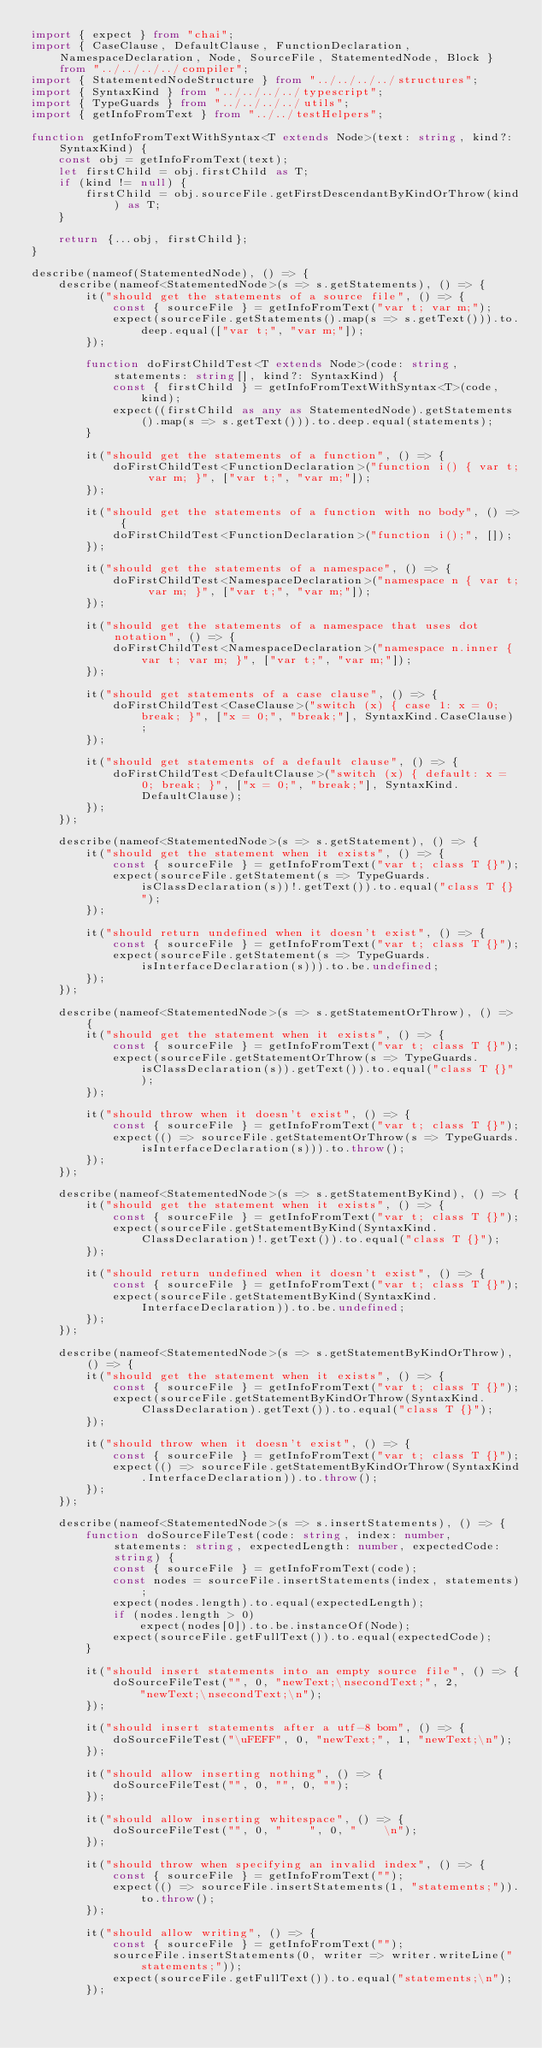<code> <loc_0><loc_0><loc_500><loc_500><_TypeScript_>import { expect } from "chai";
import { CaseClause, DefaultClause, FunctionDeclaration, NamespaceDeclaration, Node, SourceFile, StatementedNode, Block } from "../../../../compiler";
import { StatementedNodeStructure } from "../../../../structures";
import { SyntaxKind } from "../../../../typescript";
import { TypeGuards } from "../../../../utils";
import { getInfoFromText } from "../../testHelpers";

function getInfoFromTextWithSyntax<T extends Node>(text: string, kind?: SyntaxKind) {
    const obj = getInfoFromText(text);
    let firstChild = obj.firstChild as T;
    if (kind != null) {
        firstChild = obj.sourceFile.getFirstDescendantByKindOrThrow(kind) as T;
    }

    return {...obj, firstChild};
}

describe(nameof(StatementedNode), () => {
    describe(nameof<StatementedNode>(s => s.getStatements), () => {
        it("should get the statements of a source file", () => {
            const { sourceFile } = getInfoFromText("var t; var m;");
            expect(sourceFile.getStatements().map(s => s.getText())).to.deep.equal(["var t;", "var m;"]);
        });

        function doFirstChildTest<T extends Node>(code: string, statements: string[], kind?: SyntaxKind) {
            const { firstChild } = getInfoFromTextWithSyntax<T>(code, kind);
            expect((firstChild as any as StatementedNode).getStatements().map(s => s.getText())).to.deep.equal(statements);
        }

        it("should get the statements of a function", () => {
            doFirstChildTest<FunctionDeclaration>("function i() { var t; var m; }", ["var t;", "var m;"]);
        });

        it("should get the statements of a function with no body", () => {
            doFirstChildTest<FunctionDeclaration>("function i();", []);
        });

        it("should get the statements of a namespace", () => {
            doFirstChildTest<NamespaceDeclaration>("namespace n { var t; var m; }", ["var t;", "var m;"]);
        });

        it("should get the statements of a namespace that uses dot notation", () => {
            doFirstChildTest<NamespaceDeclaration>("namespace n.inner { var t; var m; }", ["var t;", "var m;"]);
        });

        it("should get statements of a case clause", () => {
            doFirstChildTest<CaseClause>("switch (x) { case 1: x = 0; break; }", ["x = 0;", "break;"], SyntaxKind.CaseClause);
        });

        it("should get statements of a default clause", () => {
            doFirstChildTest<DefaultClause>("switch (x) { default: x = 0; break; }", ["x = 0;", "break;"], SyntaxKind.DefaultClause);
        });
    });

    describe(nameof<StatementedNode>(s => s.getStatement), () => {
        it("should get the statement when it exists", () => {
            const { sourceFile } = getInfoFromText("var t; class T {}");
            expect(sourceFile.getStatement(s => TypeGuards.isClassDeclaration(s))!.getText()).to.equal("class T {}");
        });

        it("should return undefined when it doesn't exist", () => {
            const { sourceFile } = getInfoFromText("var t; class T {}");
            expect(sourceFile.getStatement(s => TypeGuards.isInterfaceDeclaration(s))).to.be.undefined;
        });
    });

    describe(nameof<StatementedNode>(s => s.getStatementOrThrow), () => {
        it("should get the statement when it exists", () => {
            const { sourceFile } = getInfoFromText("var t; class T {}");
            expect(sourceFile.getStatementOrThrow(s => TypeGuards.isClassDeclaration(s)).getText()).to.equal("class T {}");
        });

        it("should throw when it doesn't exist", () => {
            const { sourceFile } = getInfoFromText("var t; class T {}");
            expect(() => sourceFile.getStatementOrThrow(s => TypeGuards.isInterfaceDeclaration(s))).to.throw();
        });
    });

    describe(nameof<StatementedNode>(s => s.getStatementByKind), () => {
        it("should get the statement when it exists", () => {
            const { sourceFile } = getInfoFromText("var t; class T {}");
            expect(sourceFile.getStatementByKind(SyntaxKind.ClassDeclaration)!.getText()).to.equal("class T {}");
        });

        it("should return undefined when it doesn't exist", () => {
            const { sourceFile } = getInfoFromText("var t; class T {}");
            expect(sourceFile.getStatementByKind(SyntaxKind.InterfaceDeclaration)).to.be.undefined;
        });
    });

    describe(nameof<StatementedNode>(s => s.getStatementByKindOrThrow), () => {
        it("should get the statement when it exists", () => {
            const { sourceFile } = getInfoFromText("var t; class T {}");
            expect(sourceFile.getStatementByKindOrThrow(SyntaxKind.ClassDeclaration).getText()).to.equal("class T {}");
        });

        it("should throw when it doesn't exist", () => {
            const { sourceFile } = getInfoFromText("var t; class T {}");
            expect(() => sourceFile.getStatementByKindOrThrow(SyntaxKind.InterfaceDeclaration)).to.throw();
        });
    });

    describe(nameof<StatementedNode>(s => s.insertStatements), () => {
        function doSourceFileTest(code: string, index: number, statements: string, expectedLength: number, expectedCode: string) {
            const { sourceFile } = getInfoFromText(code);
            const nodes = sourceFile.insertStatements(index, statements);
            expect(nodes.length).to.equal(expectedLength);
            if (nodes.length > 0)
                expect(nodes[0]).to.be.instanceOf(Node);
            expect(sourceFile.getFullText()).to.equal(expectedCode);
        }

        it("should insert statements into an empty source file", () => {
            doSourceFileTest("", 0, "newText;\nsecondText;", 2,
                "newText;\nsecondText;\n");
        });

        it("should insert statements after a utf-8 bom", () => {
            doSourceFileTest("\uFEFF", 0, "newText;", 1, "newText;\n");
        });

        it("should allow inserting nothing", () => {
            doSourceFileTest("", 0, "", 0, "");
        });

        it("should allow inserting whitespace", () => {
            doSourceFileTest("", 0, "    ", 0, "    \n");
        });

        it("should throw when specifying an invalid index", () => {
            const { sourceFile } = getInfoFromText("");
            expect(() => sourceFile.insertStatements(1, "statements;")).to.throw();
        });

        it("should allow writing", () => {
            const { sourceFile } = getInfoFromText("");
            sourceFile.insertStatements(0, writer => writer.writeLine("statements;"));
            expect(sourceFile.getFullText()).to.equal("statements;\n");
        });
</code> 